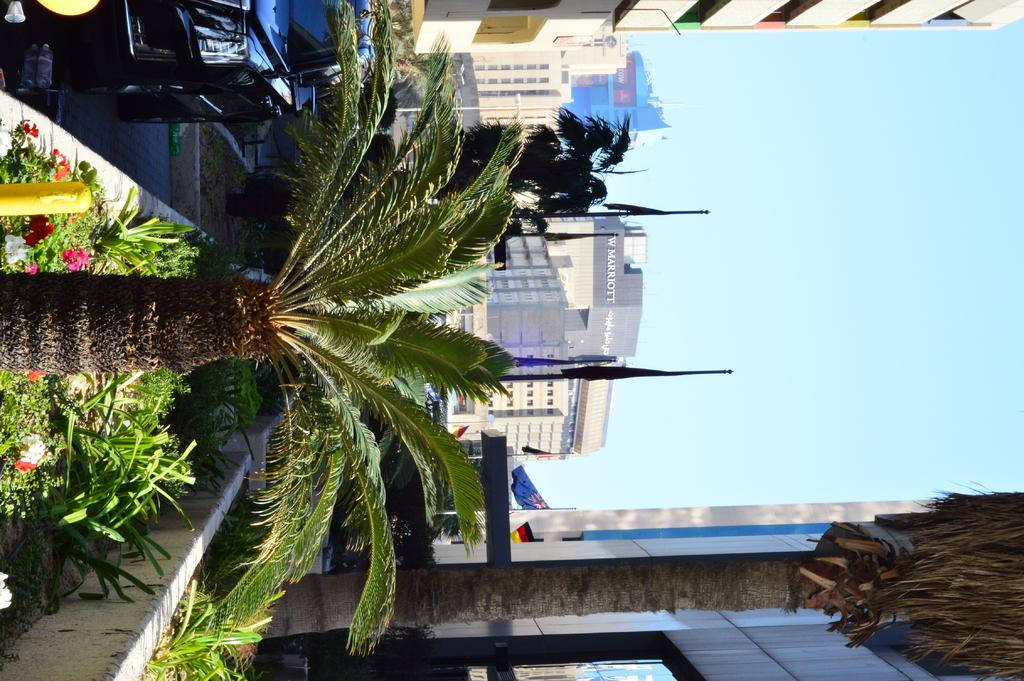What type of vegetation can be seen in the image? There are trees, plants, and flowers in the image. What man-made structures are visible in the image? There is a car, buildings, and lights in the image. What is hanging on poles in the image? Flags are hanging on poles in the image. What can be seen in the background of the image? The sky is visible in the background of the image. What type of copper liquid can be seen dripping from the car in the image? There is no copper liquid present in the image, nor is there any liquid dripping from the car. 